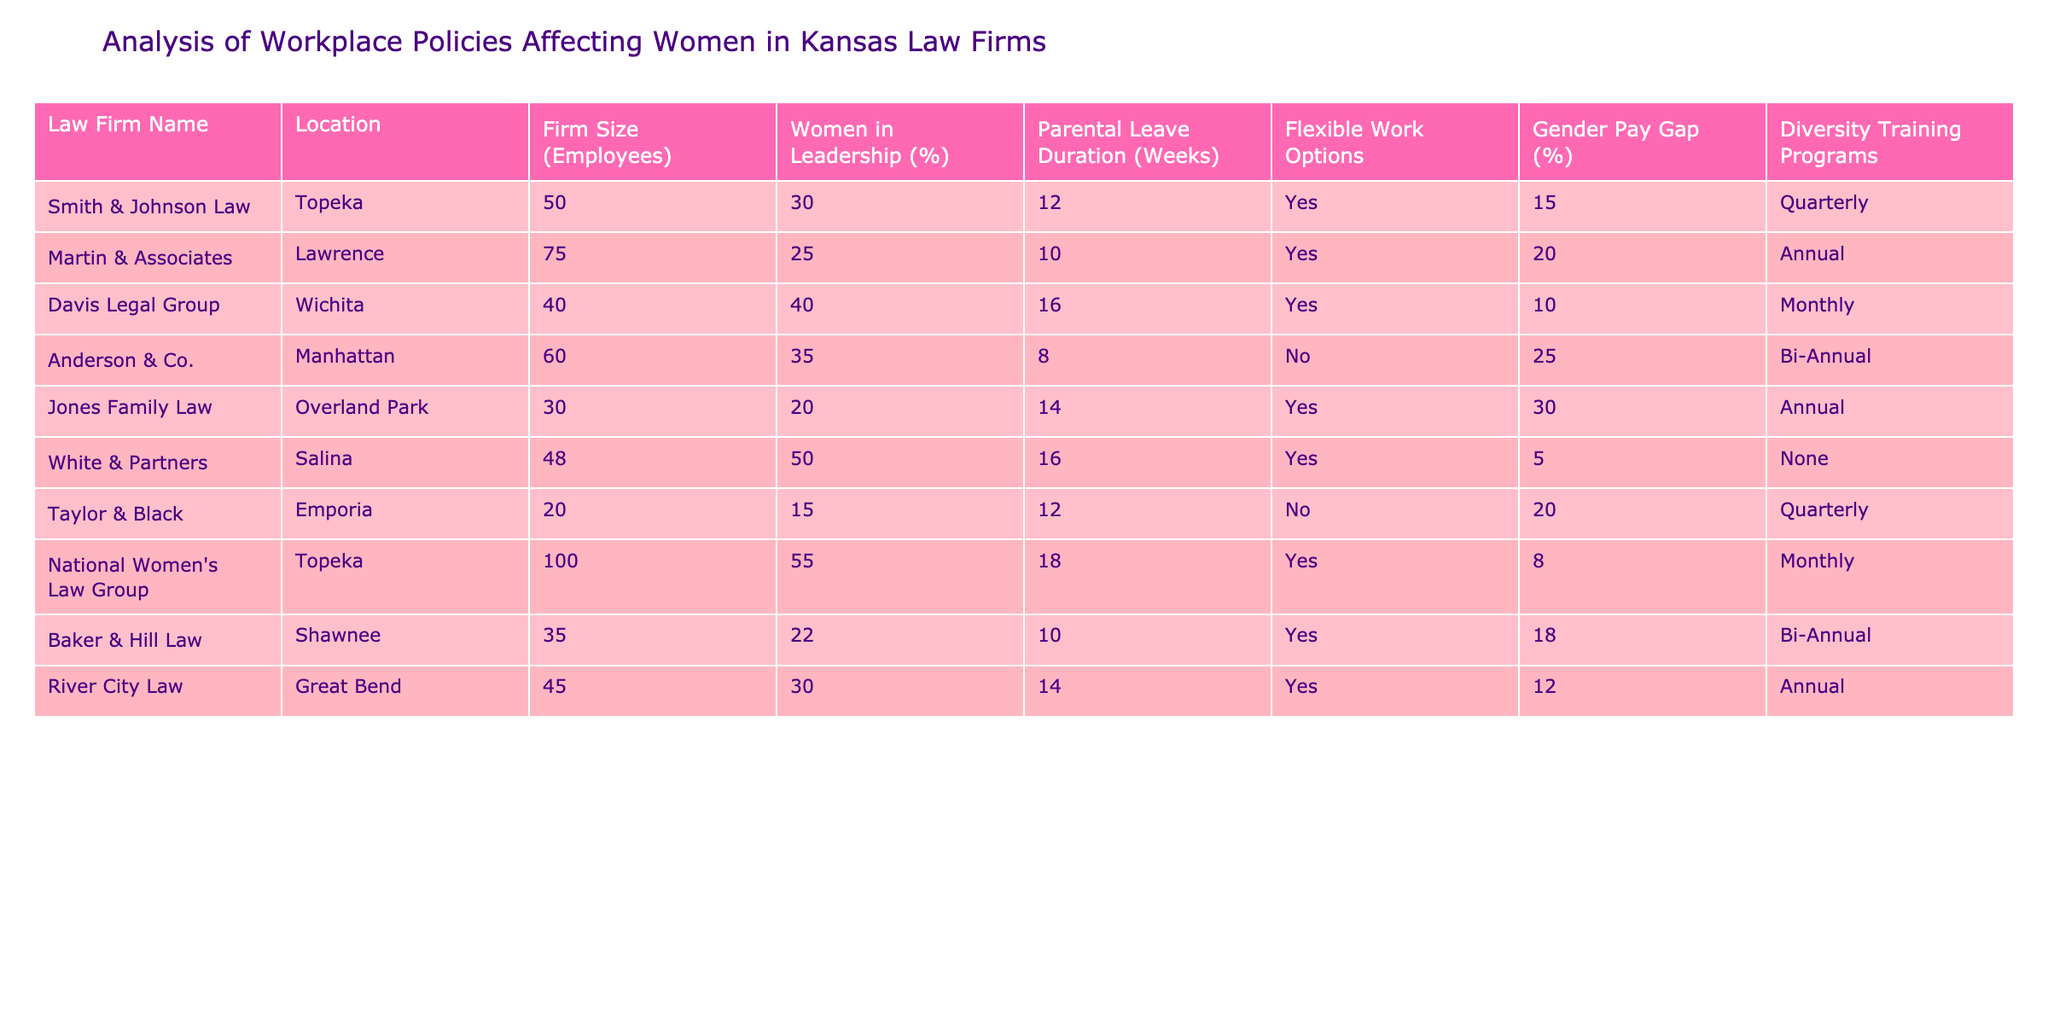What is the parental leave duration at Davis Legal Group? The table lists the parental leave duration for each law firm, and for Davis Legal Group, it specifically shows 16 weeks.
Answer: 16 weeks What percentage of women are in leadership at White & Partners? By checking the table, it indicates that the percentage of women in leadership at White & Partners is 50%.
Answer: 50% Which law firm has the highest gender pay gap and what is that percentage? The table outlines the gender pay gap for each firm. Anderson & Co. has the highest gap at 25%.
Answer: 25% How many firms offer flexible work options? By counting the "Yes" responses under the Flexible Work Options column, we find there are 6 firms that offer flexible work options out of a total of 9 firms.
Answer: 6 firms What is the average women representation in leadership among the firms listed? To find the average, we add the percentages of women in leadership: (30 + 25 + 40 + 35 + 20 + 50 + 15 + 55 + 22 + 30) = 352. There are 10 firms, so the average is 352/10 = 35.2%.
Answer: 35.2% Does Taylor & Black offer any diversity training programs? Looking at the Diversity Training Programs column, it shows that Taylor & Black has "Quarterly" as its option, which means they do offer training.
Answer: Yes Which firm has the longest parental leave duration and what is it? By scanning the Parental Leave Duration column, we can compare the values and see that National Women's Law Group has the longest duration at 18 weeks.
Answer: 18 weeks Are there any firms located in Topeka and what are their names? In the Location column, the table reveals that there are two firms in Topeka: Smith & Johnson Law and National Women's Law Group.
Answer: Smith & Johnson Law, National Women's Law Group What is the overall percentage of women in leadership among firms that do not offer flexible work options? The firms that do not offer flexible work options are Anderson & Co. and Taylor & Black, which have leadership female percentages of 35% and 15%, respectively. The average is (35 + 15) / 2 = 25%.
Answer: 25% 